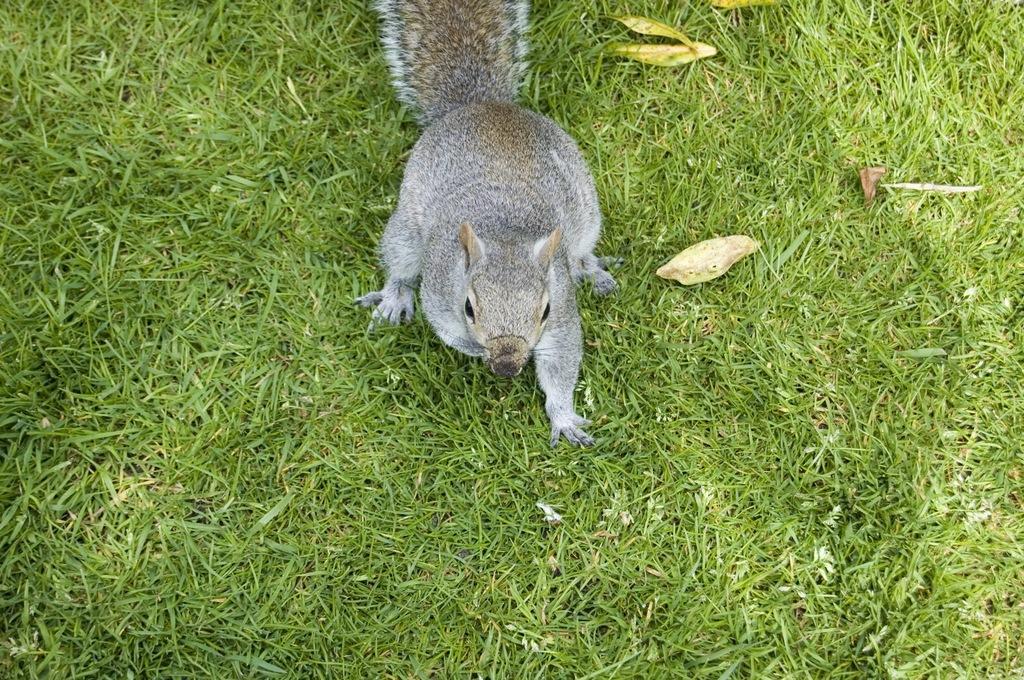Please provide a concise description of this image. In this image in the center there is a squirrel, and at the bottom there is grass and some leaves. 